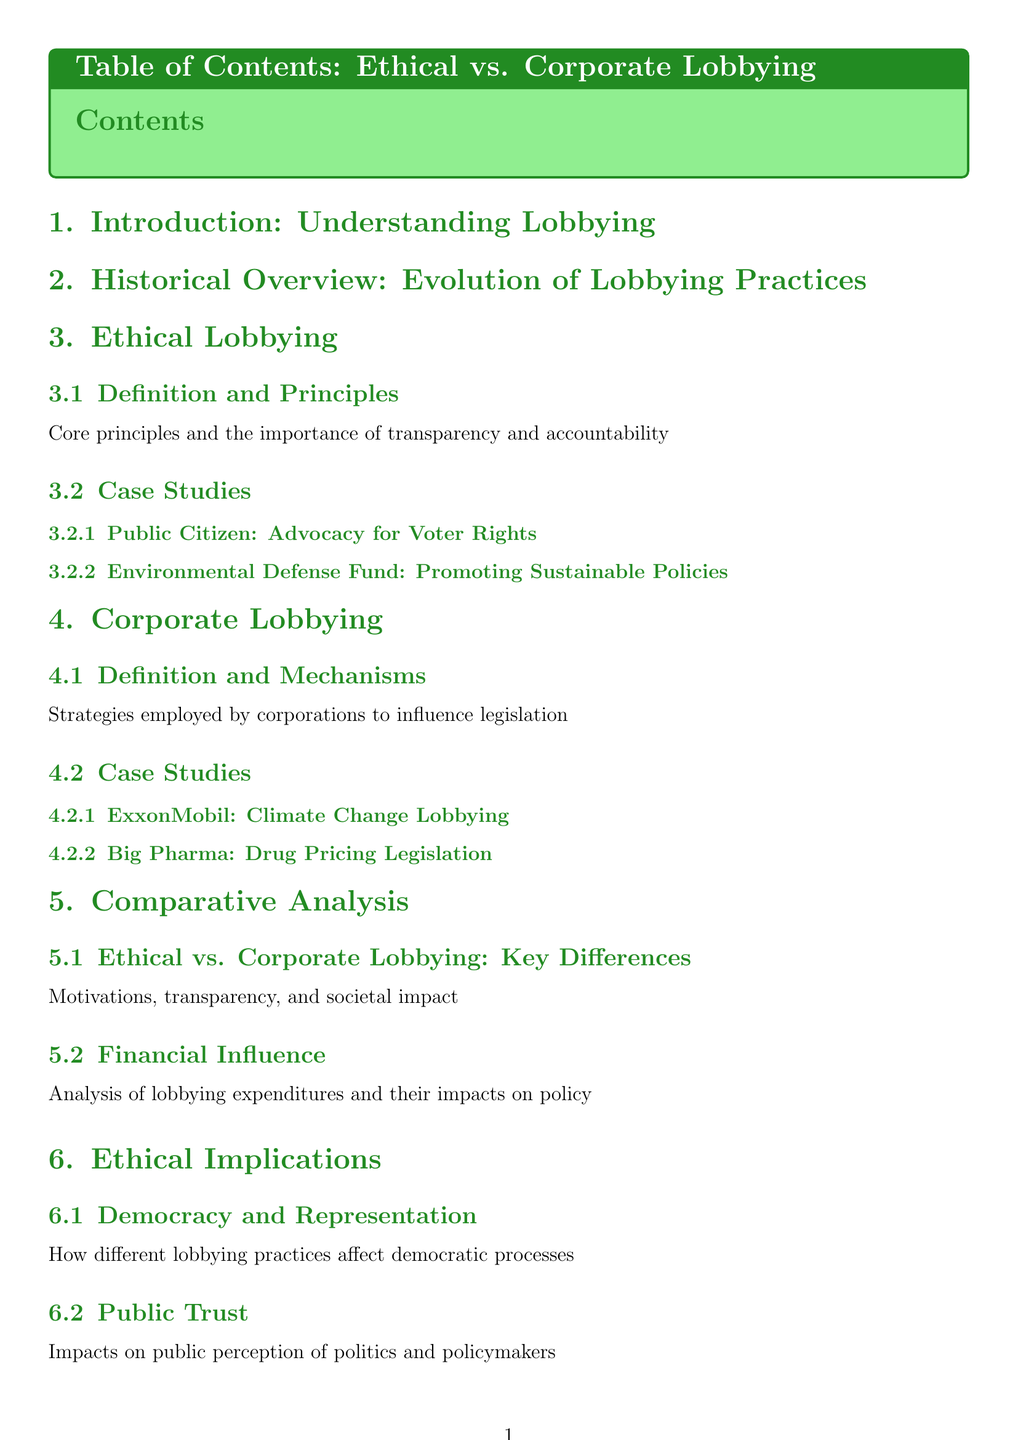What are the core principles of ethical lobbying? The document mentions the core principles and emphasizes the importance of transparency and accountability in ethical lobbying.
Answer: Transparency and accountability Who advocates for voter rights in the case studies? The document lists Public Citizen as an organization advocating for voter rights in the case studies section.
Answer: Public Citizen What is the main strategy employed by corporations in lobbying? The document defines corporate lobbying and mentions strategies employed by corporations to influence legislation.
Answer: Influence legislation What are the key differences between ethical and corporate lobbying? The document identifies motivations, transparency, and societal impact as the key differences in the comparative analysis section.
Answer: Motivations, transparency, societal impact Which organization is part of grassroots initiatives for reform? The document cites Move to Amend as an organization involved in grassroots initiatives to reform corporate influence.
Answer: Move to Amend 